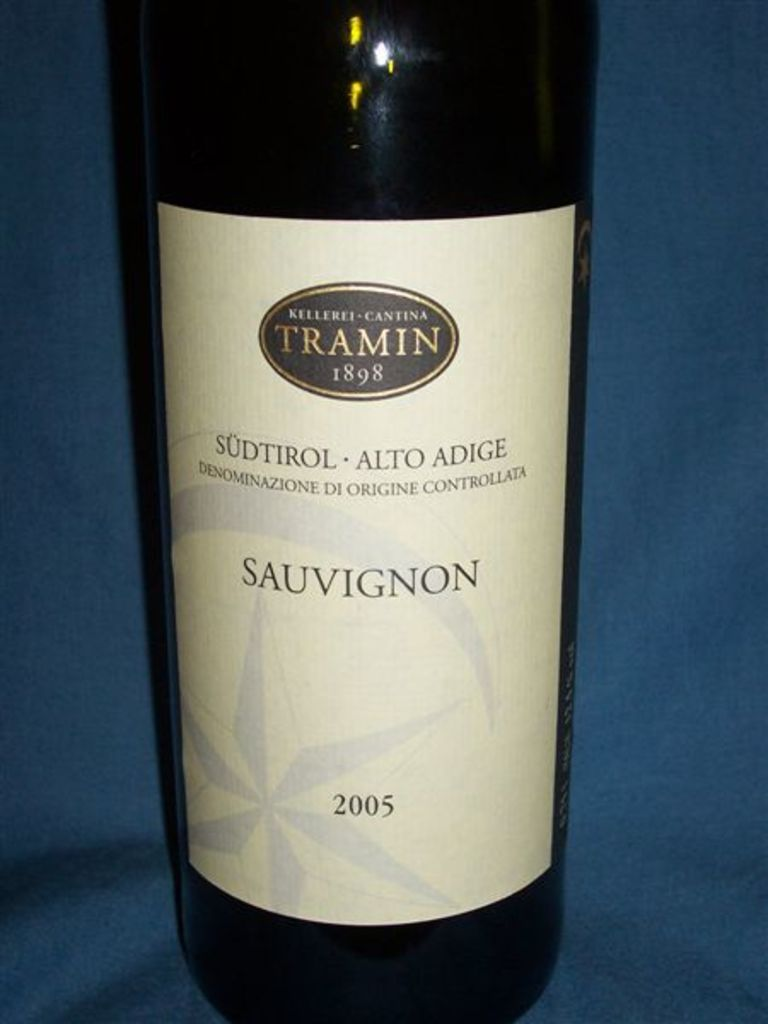What's happening in the scene? The image displays a distinguished bottle of wine from the Kellerei-Cantina Tramin, an acclaimed winery founded in 1898 in the South Tyrol region of Italy. This particular bottle is a Sauvignon, vintage 2005. The label elegantly mentions its origin "Südtirol - Alto Adige" and indicates that it's a product of controlled designation of origin (Denominazione di Origine Controllata). The presentation against a blue backdrop not only accentuates the wine's classic appearance of the label with its white background and gold script, but also stylistically enhances the perceived quality and legacy of the Tramin winery. Such a display highlights the pride in craftsmanship and heritage, characteristic of winemaking in this region. 